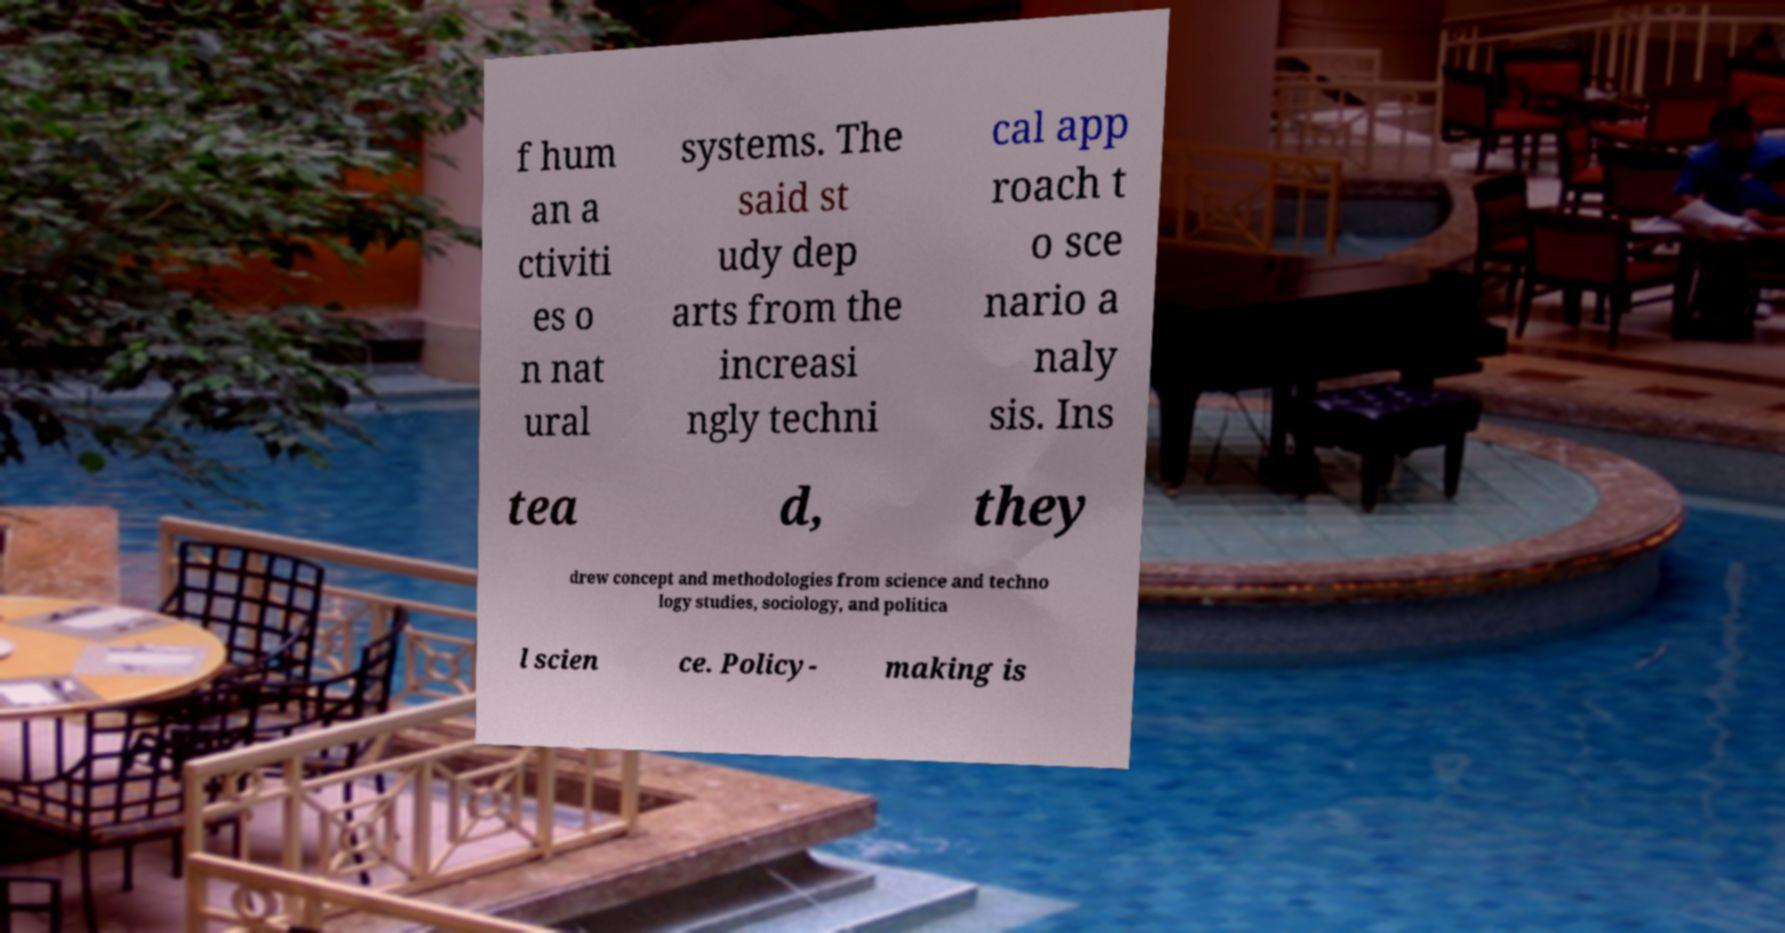Can you read and provide the text displayed in the image?This photo seems to have some interesting text. Can you extract and type it out for me? f hum an a ctiviti es o n nat ural systems. The said st udy dep arts from the increasi ngly techni cal app roach t o sce nario a naly sis. Ins tea d, they drew concept and methodologies from science and techno logy studies, sociology, and politica l scien ce. Policy- making is 